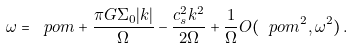Convert formula to latex. <formula><loc_0><loc_0><loc_500><loc_500>\omega = \ p o m + \frac { \pi G \Sigma _ { 0 } | k | } { \Omega } - \frac { c _ { s } ^ { 2 } k ^ { 2 } } { 2 \Omega } + \frac { 1 } { \Omega } O ( \ p o m ^ { 2 } , \omega ^ { 2 } ) \, .</formula> 